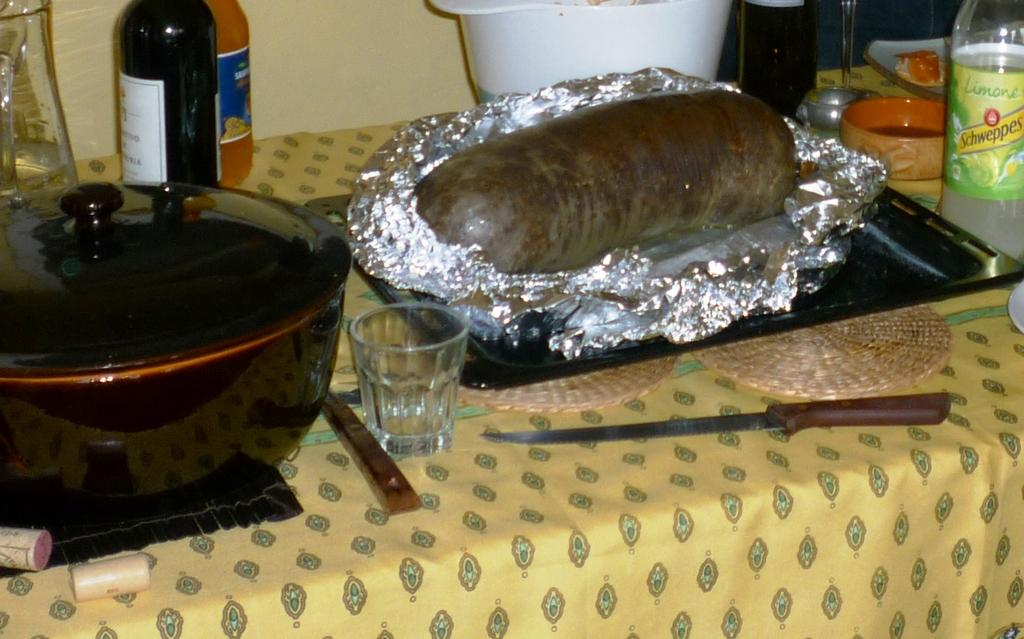<image>
Create a compact narrative representing the image presented. A table with a bottle of Schweppes on it. 